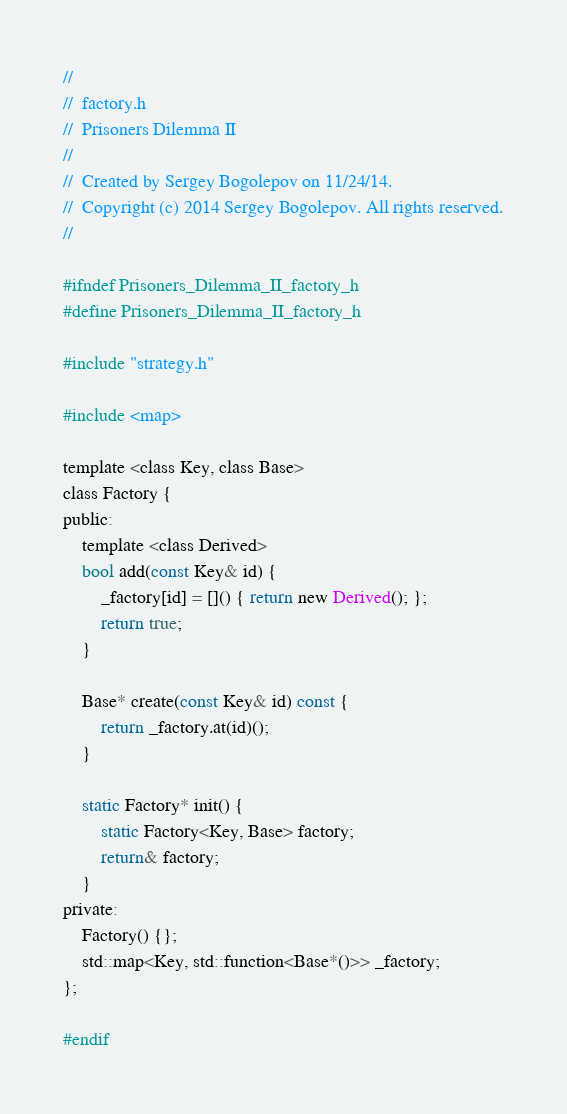Convert code to text. <code><loc_0><loc_0><loc_500><loc_500><_C_>//
//  factory.h
//  Prisoners Dilemma II
//
//  Created by Sergey Bogolepov on 11/24/14.
//  Copyright (c) 2014 Sergey Bogolepov. All rights reserved.
//

#ifndef Prisoners_Dilemma_II_factory_h
#define Prisoners_Dilemma_II_factory_h

#include "strategy.h"

#include <map>

template <class Key, class Base>
class Factory {
public:
    template <class Derived>
    bool add(const Key& id) {
        _factory[id] = []() { return new Derived(); };
        return true;
    }
    
    Base* create(const Key& id) const {
        return _factory.at(id)();
    }
    
    static Factory* init() {
        static Factory<Key, Base> factory;
        return& factory;
    }
private:
    Factory() {};
    std::map<Key, std::function<Base*()>> _factory;
};

#endif
</code> 